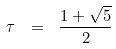Convert formula to latex. <formula><loc_0><loc_0><loc_500><loc_500>\tau \ = \ \frac { 1 + \sqrt { 5 } } { 2 }</formula> 